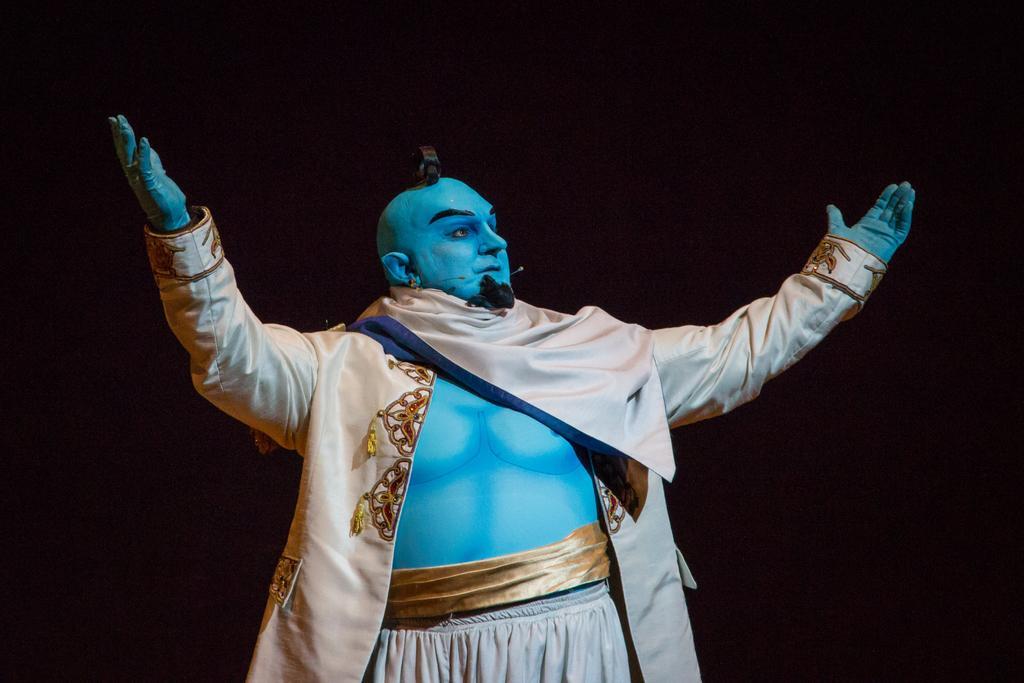How would you summarize this image in a sentence or two? In this picture there is a man who is wearing a shirt and trouser. He is looking like a genie. In the background i can see the darkness. He is also wearing microphone. 